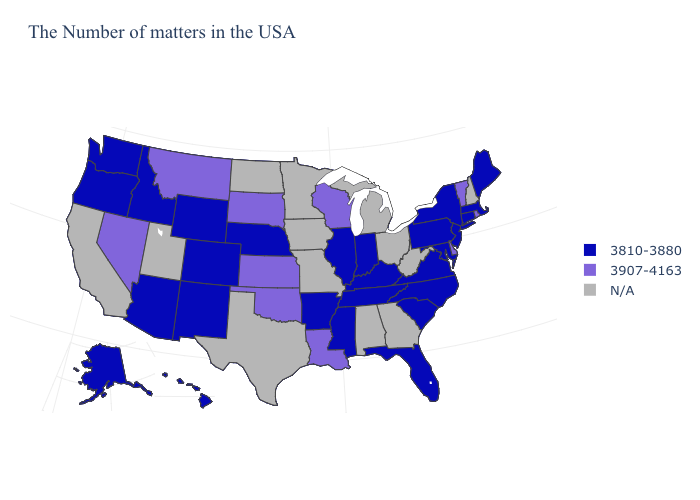What is the value of South Carolina?
Give a very brief answer. 3810-3880. What is the value of South Dakota?
Be succinct. 3907-4163. Which states hav the highest value in the South?
Quick response, please. Delaware, Louisiana, Oklahoma. Name the states that have a value in the range 3810-3880?
Give a very brief answer. Maine, Massachusetts, Connecticut, New York, New Jersey, Maryland, Pennsylvania, Virginia, North Carolina, South Carolina, Florida, Kentucky, Indiana, Tennessee, Illinois, Mississippi, Arkansas, Nebraska, Wyoming, Colorado, New Mexico, Arizona, Idaho, Washington, Oregon, Alaska, Hawaii. What is the value of Kentucky?
Concise answer only. 3810-3880. What is the value of Nevada?
Be succinct. 3907-4163. Does Rhode Island have the highest value in the USA?
Give a very brief answer. Yes. What is the value of South Carolina?
Quick response, please. 3810-3880. Name the states that have a value in the range N/A?
Write a very short answer. New Hampshire, West Virginia, Ohio, Georgia, Michigan, Alabama, Missouri, Minnesota, Iowa, Texas, North Dakota, Utah, California. Does Kansas have the highest value in the MidWest?
Keep it brief. Yes. Among the states that border Oregon , does Nevada have the highest value?
Write a very short answer. Yes. Does Colorado have the lowest value in the West?
Be succinct. Yes. Name the states that have a value in the range N/A?
Quick response, please. New Hampshire, West Virginia, Ohio, Georgia, Michigan, Alabama, Missouri, Minnesota, Iowa, Texas, North Dakota, Utah, California. Which states have the lowest value in the USA?
Write a very short answer. Maine, Massachusetts, Connecticut, New York, New Jersey, Maryland, Pennsylvania, Virginia, North Carolina, South Carolina, Florida, Kentucky, Indiana, Tennessee, Illinois, Mississippi, Arkansas, Nebraska, Wyoming, Colorado, New Mexico, Arizona, Idaho, Washington, Oregon, Alaska, Hawaii. Does the map have missing data?
Answer briefly. Yes. 